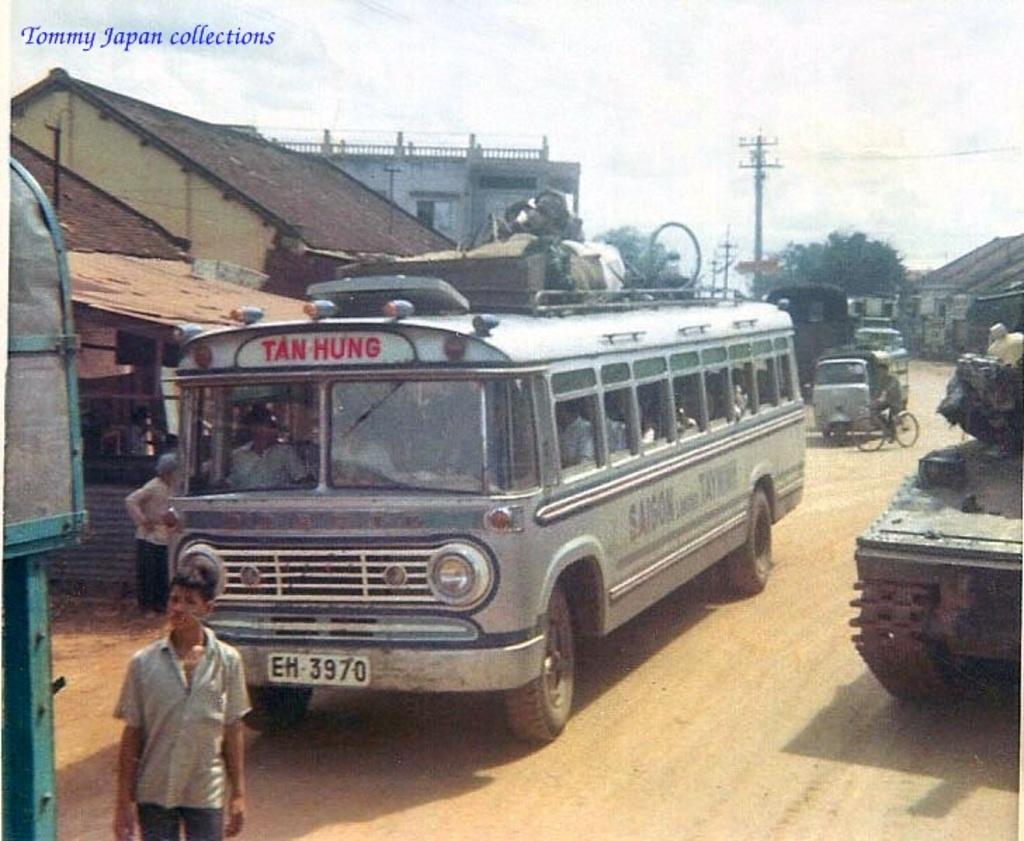<image>
Offer a succinct explanation of the picture presented. A bus, heading for Tan Hung, has a license plate which reads "EH 3970." 